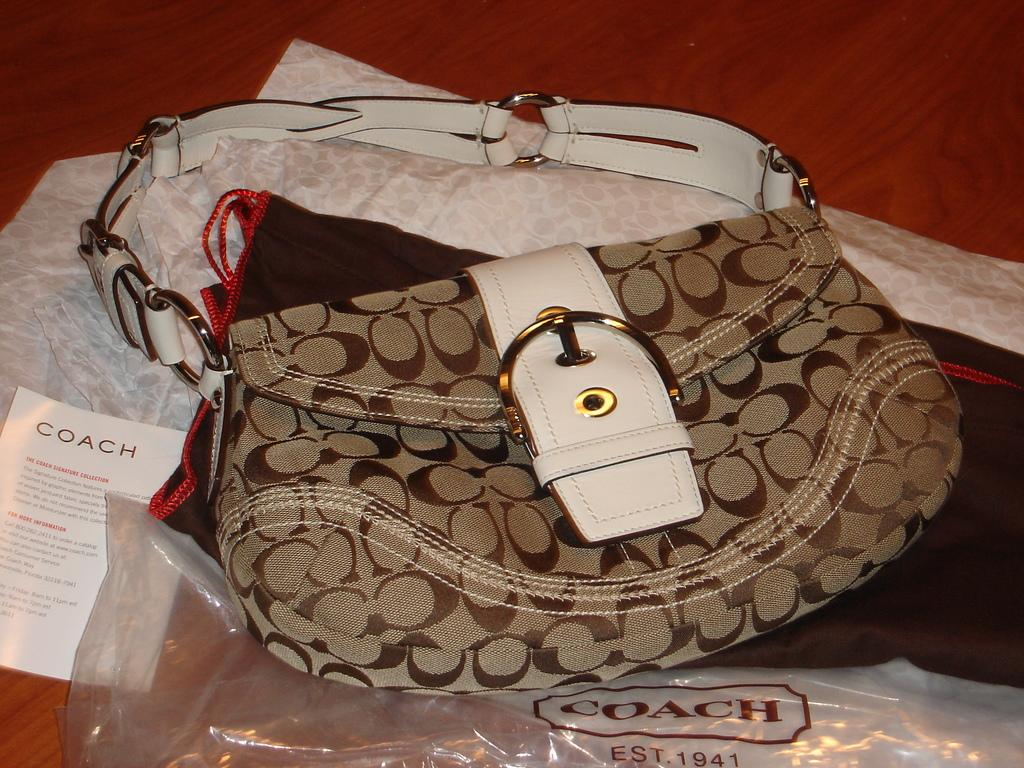What object is placed on the table in the image? There is a bag on the table in the image. What type of material can be seen in the image? There is paper in the image. What might be used to cover or protect something in the image? There is a cover in the image. What brand of toothpaste is advertised on the van in the image? There is no van present in the image, so it is not possible to determine what brand of toothpaste might be advertised. How many members are on the team in the image? There is no team present in the image, so it is not possible to determine the number of members. 